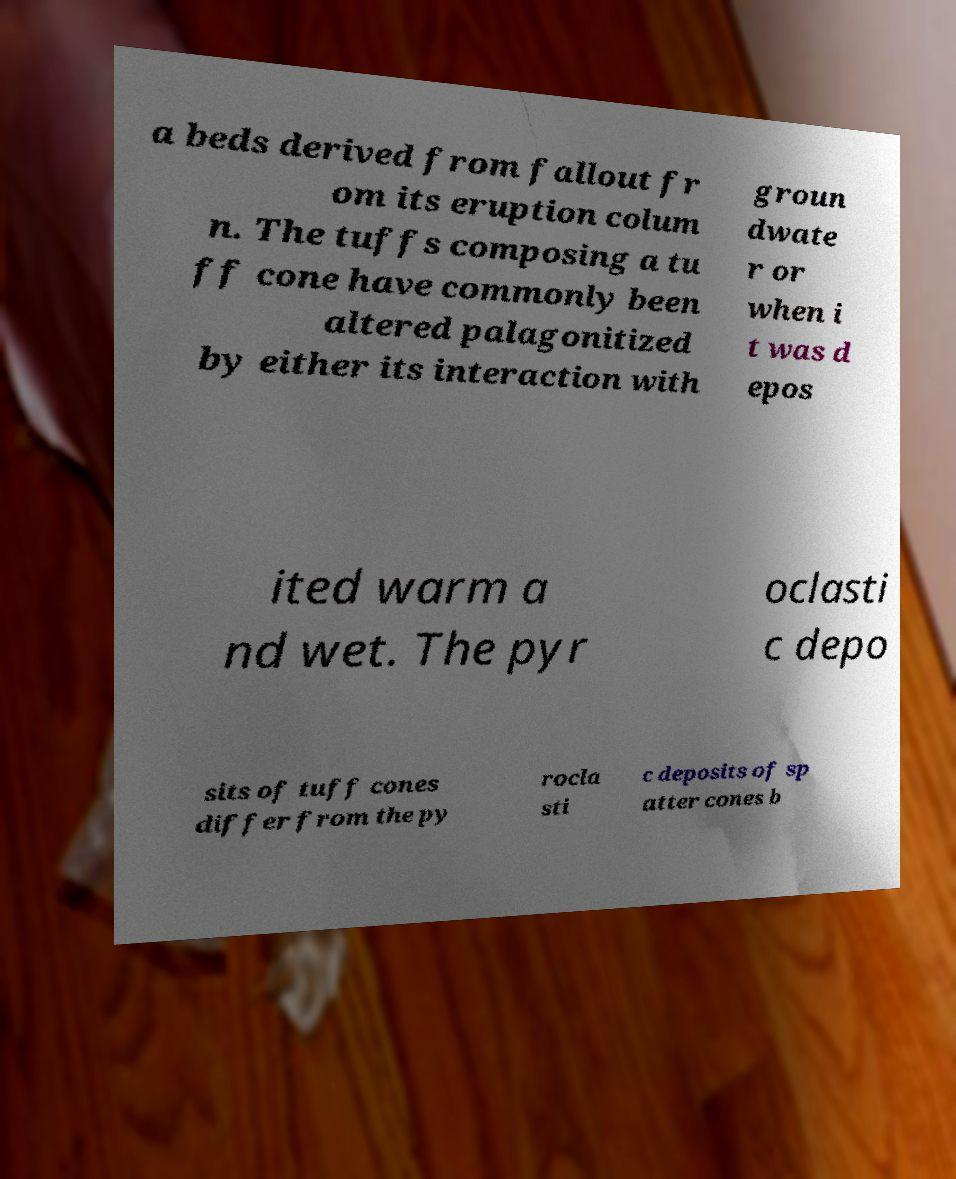Can you accurately transcribe the text from the provided image for me? a beds derived from fallout fr om its eruption colum n. The tuffs composing a tu ff cone have commonly been altered palagonitized by either its interaction with groun dwate r or when i t was d epos ited warm a nd wet. The pyr oclasti c depo sits of tuff cones differ from the py rocla sti c deposits of sp atter cones b 